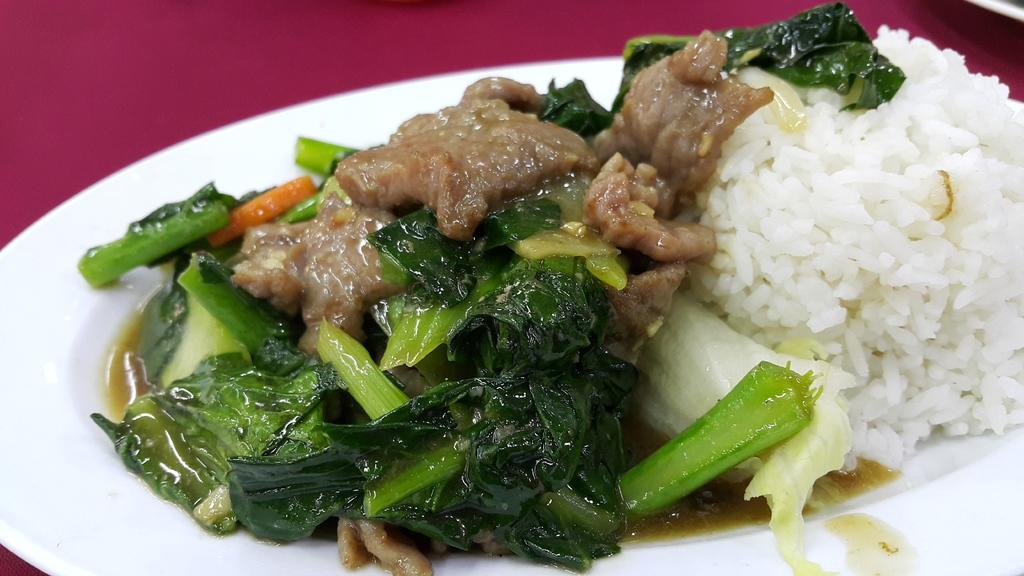What color is the background of the image? The background of the image is maroon in color. What can be seen on the plate in the image? There is food on the plate in the image. What types of food are included on the plate? The food includes rice and green leaf vegetables. How does the daughter feel about the temper of the fold in the image? There is no daughter, temper, or fold present in the image. 